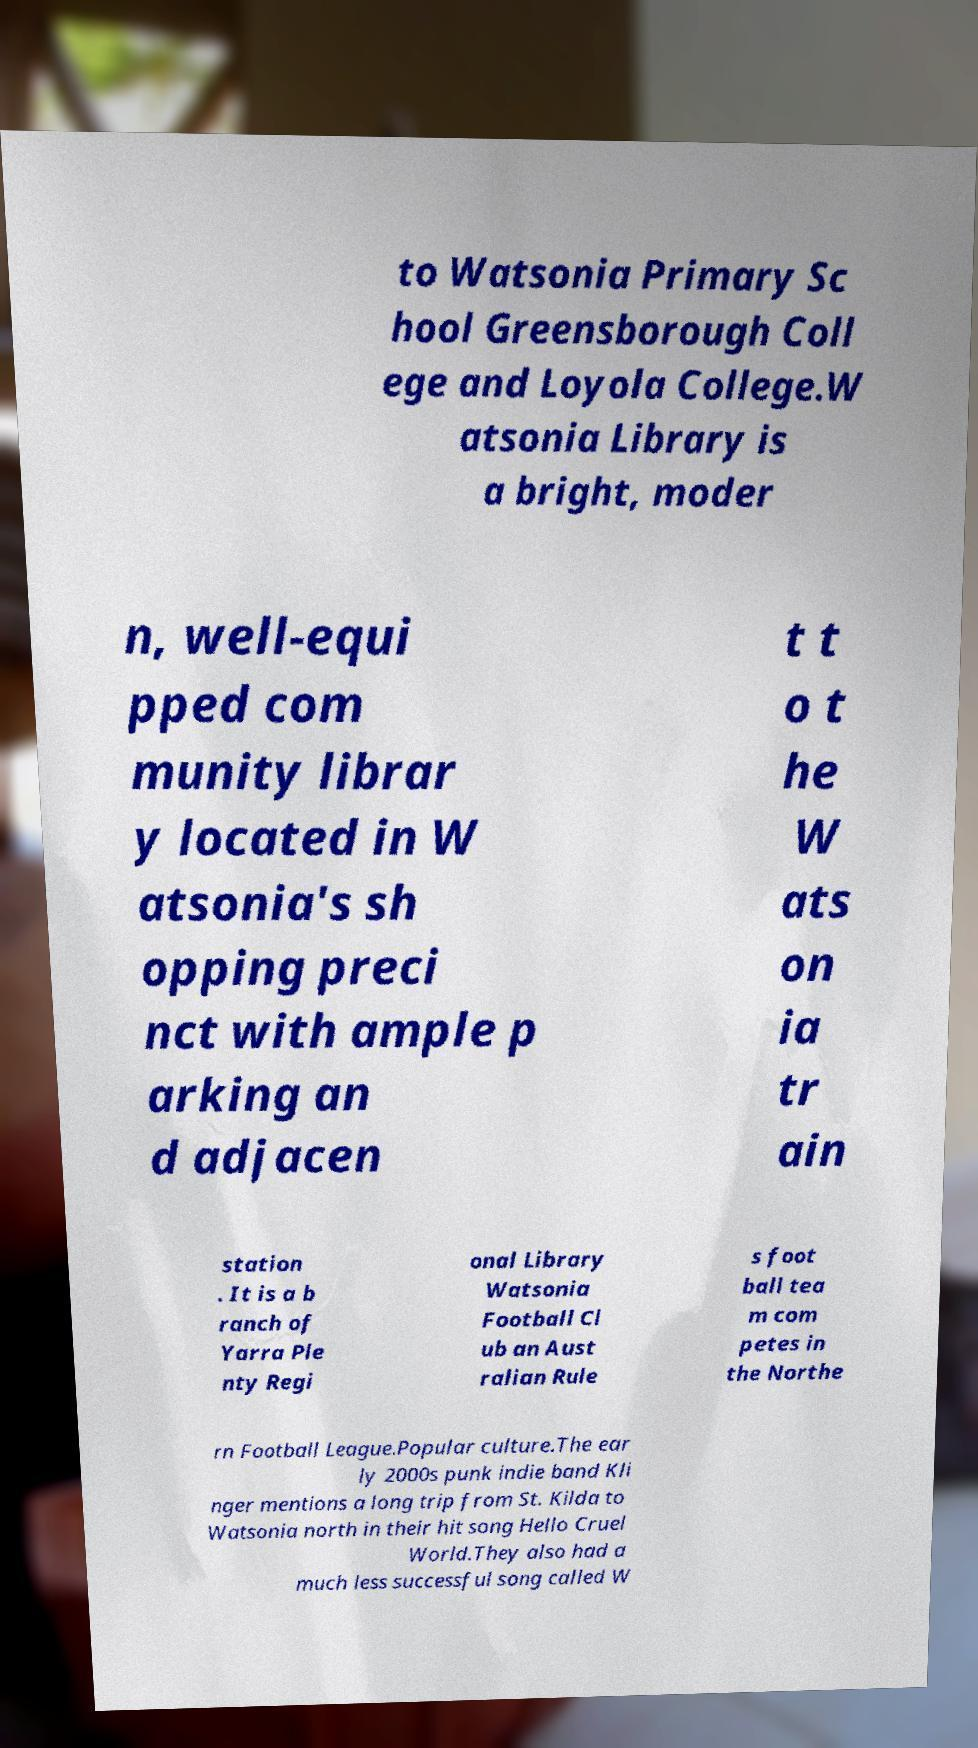Can you read and provide the text displayed in the image?This photo seems to have some interesting text. Can you extract and type it out for me? to Watsonia Primary Sc hool Greensborough Coll ege and Loyola College.W atsonia Library is a bright, moder n, well-equi pped com munity librar y located in W atsonia's sh opping preci nct with ample p arking an d adjacen t t o t he W ats on ia tr ain station . It is a b ranch of Yarra Ple nty Regi onal Library Watsonia Football Cl ub an Aust ralian Rule s foot ball tea m com petes in the Northe rn Football League.Popular culture.The ear ly 2000s punk indie band Kli nger mentions a long trip from St. Kilda to Watsonia north in their hit song Hello Cruel World.They also had a much less successful song called W 